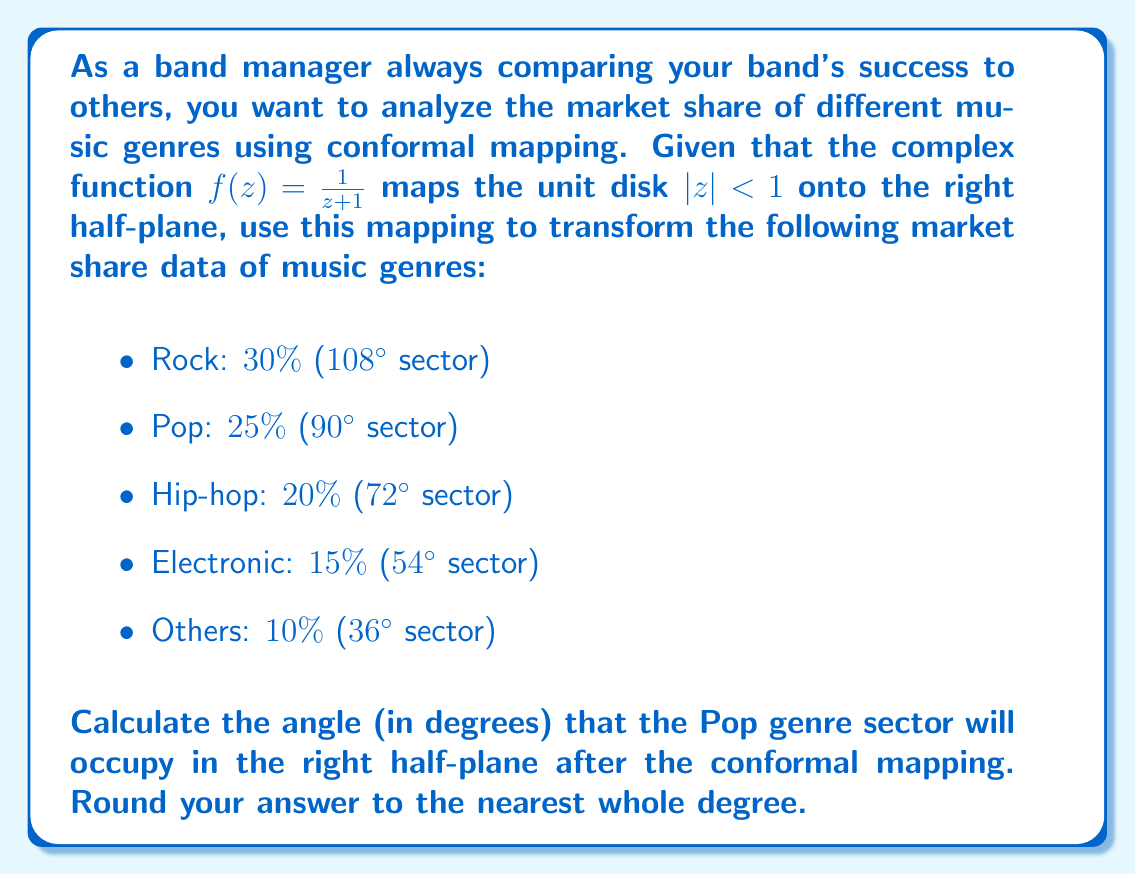Teach me how to tackle this problem. To solve this problem, we'll follow these steps:

1) First, recall that conformal mappings preserve angles locally. This means that the relative angles between sectors will remain the same after the mapping.

2) The unit disk is being mapped to the right half-plane. In this mapping, the circle $|z| = 1$ (except for $z = -1$) is mapped to the imaginary axis.

3) The point $z = 1$ on the unit circle is mapped to $f(1) = \frac{1}{1+1} = \frac{1}{2}$ on the real axis.

4) The point $z = -1$ on the unit circle is the point at infinity in the right half-plane.

5) This means that the entire unit disk is "opened up" and stretched over the right half-plane, with the line from $z = -1$ to $z = 1$ on the unit circle becoming the entire imaginary axis.

6) In the original data, the Pop genre occupies a $90^\circ$ sector out of the full $360^\circ$ circle.

7) After the mapping, this sector will occupy an angle from the positive real axis to a line in the right half-plane.

8) To calculate this angle, we need to consider how the $360^\circ$ of the unit circle are distributed in the right half-plane:
   - The $180^\circ$ from $z = -1$ to $z = 1$ (counterclockwise) becomes the entire positive imaginary axis ($90^\circ$ in the right half-plane).
   - The other $180^\circ$ from $z = 1$ to $z = -1$ (counterclockwise) becomes the entire negative imaginary axis ($90^\circ$ in the right half-plane).

9) This means that angles in the right half-plane are halved compared to their original measure in the unit disk.

10) Therefore, the $90^\circ$ Pop sector in the unit disk will occupy a $45^\circ$ angle in the right half-plane after the conformal mapping.
Answer: $45^\circ$ 